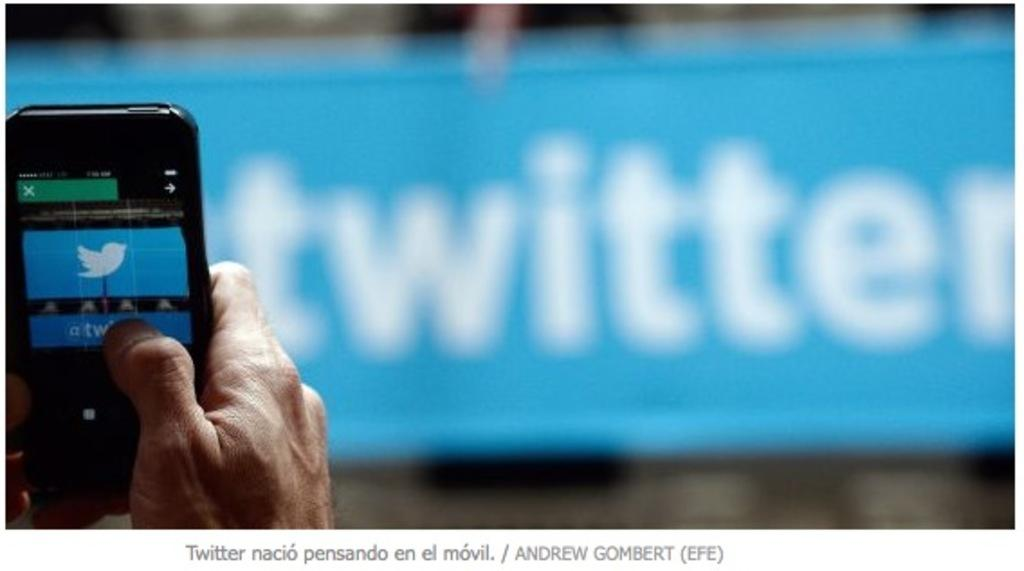Provide a one-sentence caption for the provided image. Man taking a picture with cell phone of a twitter banner. 